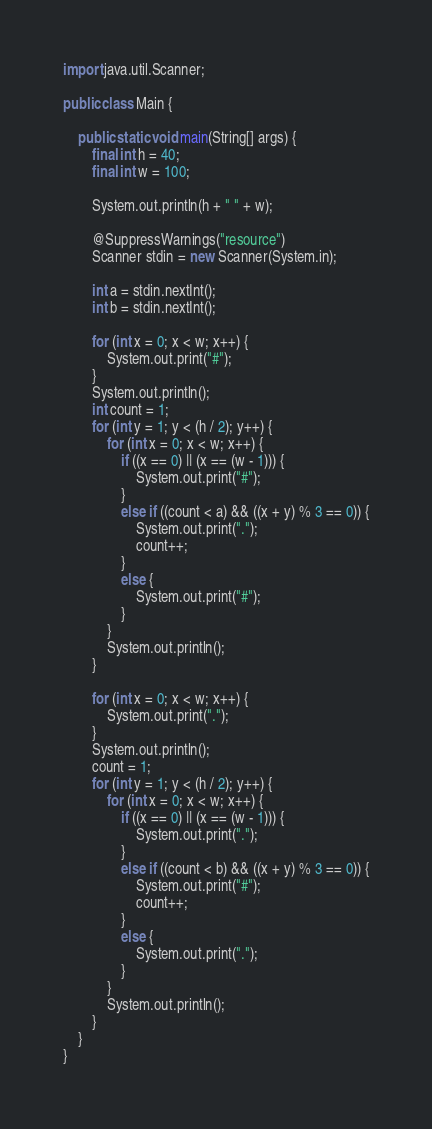<code> <loc_0><loc_0><loc_500><loc_500><_Java_>import java.util.Scanner;

public class Main {

	public static void main(String[] args) {
		final int h = 40;
		final int w = 100;

		System.out.println(h + " " + w);

		@SuppressWarnings("resource")
		Scanner stdin = new Scanner(System.in);

		int a = stdin.nextInt();
		int b = stdin.nextInt();

		for (int x = 0; x < w; x++) {
			System.out.print("#");
		}
		System.out.println();
		int count = 1;
		for (int y = 1; y < (h / 2); y++) {
			for (int x = 0; x < w; x++) {
				if ((x == 0) || (x == (w - 1))) {
					System.out.print("#");
				}
				else if ((count < a) && ((x + y) % 3 == 0)) {
					System.out.print(".");
					count++;
				}
				else {
					System.out.print("#");
				}
			}
			System.out.println();
		}

		for (int x = 0; x < w; x++) {
			System.out.print(".");
		}
		System.out.println();
		count = 1;
		for (int y = 1; y < (h / 2); y++) {
			for (int x = 0; x < w; x++) {
				if ((x == 0) || (x == (w - 1))) {
					System.out.print(".");
				}
				else if ((count < b) && ((x + y) % 3 == 0)) {
					System.out.print("#");
					count++;
				}
				else {
					System.out.print(".");
				}
			}
			System.out.println();
		}
	}
}
</code> 